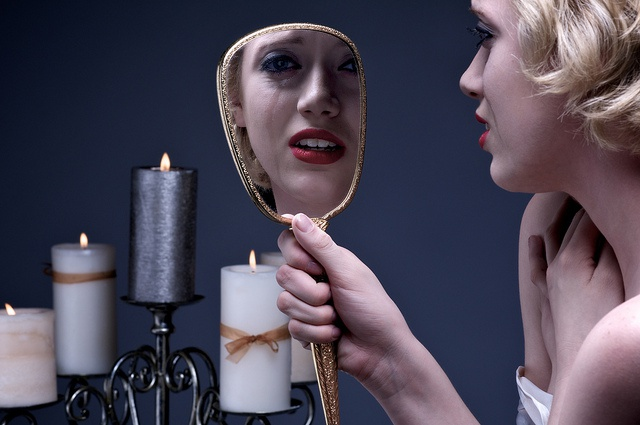Describe the objects in this image and their specific colors. I can see people in black, gray, darkgray, and maroon tones in this image. 